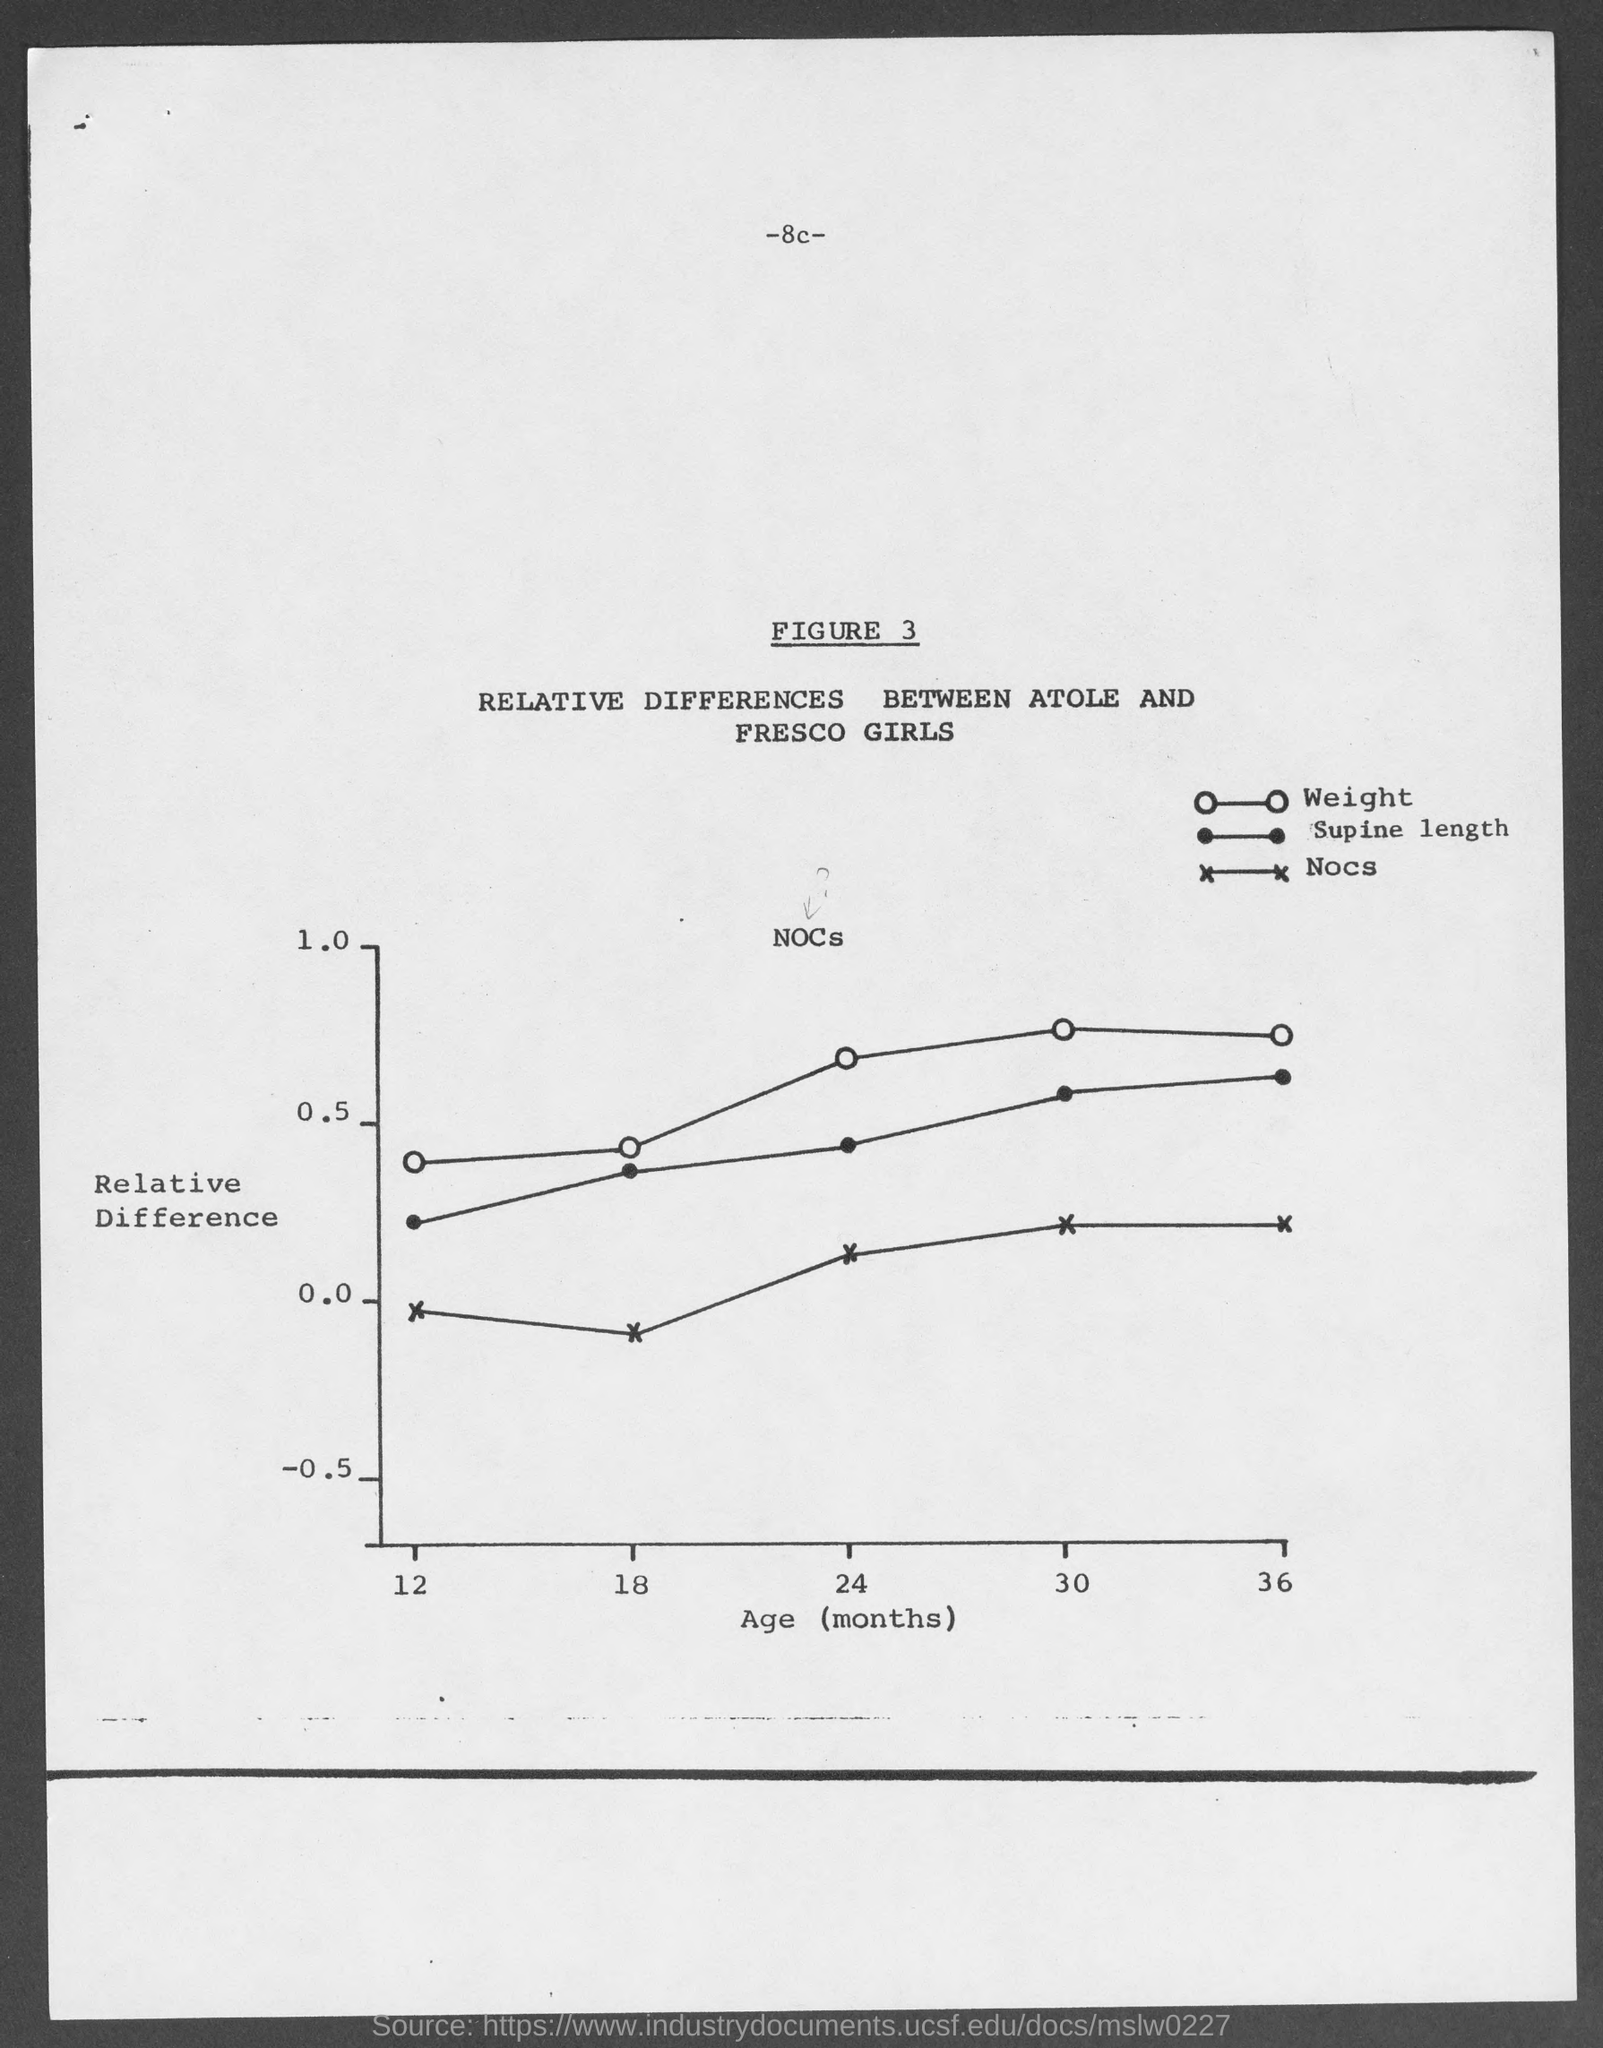What is the figure no.?
Provide a short and direct response. Figure 3. 